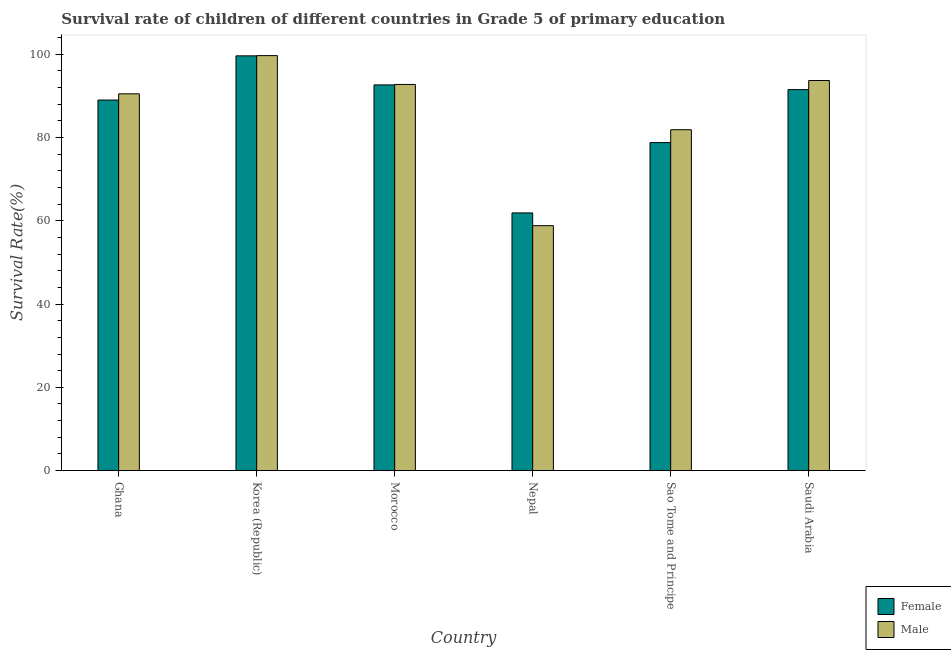How many different coloured bars are there?
Ensure brevity in your answer.  2. How many groups of bars are there?
Make the answer very short. 6. Are the number of bars on each tick of the X-axis equal?
Offer a terse response. Yes. What is the label of the 6th group of bars from the left?
Your answer should be compact. Saudi Arabia. In how many cases, is the number of bars for a given country not equal to the number of legend labels?
Offer a terse response. 0. What is the survival rate of male students in primary education in Korea (Republic)?
Offer a terse response. 99.67. Across all countries, what is the maximum survival rate of female students in primary education?
Keep it short and to the point. 99.62. Across all countries, what is the minimum survival rate of female students in primary education?
Your response must be concise. 61.89. In which country was the survival rate of male students in primary education maximum?
Your response must be concise. Korea (Republic). In which country was the survival rate of female students in primary education minimum?
Offer a very short reply. Nepal. What is the total survival rate of female students in primary education in the graph?
Make the answer very short. 513.42. What is the difference between the survival rate of female students in primary education in Nepal and that in Sao Tome and Principe?
Give a very brief answer. -16.89. What is the difference between the survival rate of female students in primary education in Korea (Republic) and the survival rate of male students in primary education in Nepal?
Give a very brief answer. 40.79. What is the average survival rate of female students in primary education per country?
Keep it short and to the point. 85.57. What is the difference between the survival rate of female students in primary education and survival rate of male students in primary education in Sao Tome and Principe?
Provide a succinct answer. -3.09. In how many countries, is the survival rate of male students in primary education greater than 48 %?
Provide a short and direct response. 6. What is the ratio of the survival rate of female students in primary education in Nepal to that in Sao Tome and Principe?
Make the answer very short. 0.79. Is the survival rate of male students in primary education in Ghana less than that in Morocco?
Give a very brief answer. Yes. Is the difference between the survival rate of female students in primary education in Nepal and Sao Tome and Principe greater than the difference between the survival rate of male students in primary education in Nepal and Sao Tome and Principe?
Keep it short and to the point. Yes. What is the difference between the highest and the second highest survival rate of male students in primary education?
Offer a terse response. 5.98. What is the difference between the highest and the lowest survival rate of female students in primary education?
Offer a terse response. 37.73. Is the sum of the survival rate of male students in primary education in Korea (Republic) and Sao Tome and Principe greater than the maximum survival rate of female students in primary education across all countries?
Your answer should be compact. Yes. What does the 1st bar from the left in Nepal represents?
Make the answer very short. Female. Does the graph contain grids?
Make the answer very short. No. What is the title of the graph?
Give a very brief answer. Survival rate of children of different countries in Grade 5 of primary education. Does "National Visitors" appear as one of the legend labels in the graph?
Your answer should be compact. No. What is the label or title of the Y-axis?
Your response must be concise. Survival Rate(%). What is the Survival Rate(%) of Female in Ghana?
Provide a succinct answer. 89. What is the Survival Rate(%) in Male in Ghana?
Provide a short and direct response. 90.49. What is the Survival Rate(%) in Female in Korea (Republic)?
Provide a short and direct response. 99.62. What is the Survival Rate(%) of Male in Korea (Republic)?
Give a very brief answer. 99.67. What is the Survival Rate(%) of Female in Morocco?
Give a very brief answer. 92.64. What is the Survival Rate(%) in Male in Morocco?
Provide a succinct answer. 92.75. What is the Survival Rate(%) of Female in Nepal?
Provide a short and direct response. 61.89. What is the Survival Rate(%) of Male in Nepal?
Offer a terse response. 58.83. What is the Survival Rate(%) of Female in Sao Tome and Principe?
Ensure brevity in your answer.  78.78. What is the Survival Rate(%) of Male in Sao Tome and Principe?
Give a very brief answer. 81.87. What is the Survival Rate(%) in Female in Saudi Arabia?
Give a very brief answer. 91.5. What is the Survival Rate(%) in Male in Saudi Arabia?
Provide a short and direct response. 93.69. Across all countries, what is the maximum Survival Rate(%) in Female?
Provide a succinct answer. 99.62. Across all countries, what is the maximum Survival Rate(%) in Male?
Your answer should be compact. 99.67. Across all countries, what is the minimum Survival Rate(%) of Female?
Ensure brevity in your answer.  61.89. Across all countries, what is the minimum Survival Rate(%) in Male?
Provide a short and direct response. 58.83. What is the total Survival Rate(%) in Female in the graph?
Offer a terse response. 513.42. What is the total Survival Rate(%) of Male in the graph?
Ensure brevity in your answer.  517.31. What is the difference between the Survival Rate(%) of Female in Ghana and that in Korea (Republic)?
Ensure brevity in your answer.  -10.62. What is the difference between the Survival Rate(%) in Male in Ghana and that in Korea (Republic)?
Your answer should be compact. -9.18. What is the difference between the Survival Rate(%) of Female in Ghana and that in Morocco?
Ensure brevity in your answer.  -3.64. What is the difference between the Survival Rate(%) in Male in Ghana and that in Morocco?
Offer a terse response. -2.25. What is the difference between the Survival Rate(%) of Female in Ghana and that in Nepal?
Give a very brief answer. 27.11. What is the difference between the Survival Rate(%) of Male in Ghana and that in Nepal?
Your answer should be very brief. 31.67. What is the difference between the Survival Rate(%) in Female in Ghana and that in Sao Tome and Principe?
Your response must be concise. 10.22. What is the difference between the Survival Rate(%) in Male in Ghana and that in Sao Tome and Principe?
Your response must be concise. 8.62. What is the difference between the Survival Rate(%) in Female in Ghana and that in Saudi Arabia?
Offer a terse response. -2.5. What is the difference between the Survival Rate(%) in Male in Ghana and that in Saudi Arabia?
Keep it short and to the point. -3.2. What is the difference between the Survival Rate(%) of Female in Korea (Republic) and that in Morocco?
Your answer should be compact. 6.98. What is the difference between the Survival Rate(%) in Male in Korea (Republic) and that in Morocco?
Offer a very short reply. 6.92. What is the difference between the Survival Rate(%) in Female in Korea (Republic) and that in Nepal?
Provide a short and direct response. 37.73. What is the difference between the Survival Rate(%) of Male in Korea (Republic) and that in Nepal?
Offer a terse response. 40.84. What is the difference between the Survival Rate(%) in Female in Korea (Republic) and that in Sao Tome and Principe?
Make the answer very short. 20.84. What is the difference between the Survival Rate(%) in Male in Korea (Republic) and that in Sao Tome and Principe?
Give a very brief answer. 17.8. What is the difference between the Survival Rate(%) in Female in Korea (Republic) and that in Saudi Arabia?
Your answer should be very brief. 8.12. What is the difference between the Survival Rate(%) of Male in Korea (Republic) and that in Saudi Arabia?
Offer a very short reply. 5.98. What is the difference between the Survival Rate(%) in Female in Morocco and that in Nepal?
Your answer should be compact. 30.75. What is the difference between the Survival Rate(%) of Male in Morocco and that in Nepal?
Ensure brevity in your answer.  33.92. What is the difference between the Survival Rate(%) in Female in Morocco and that in Sao Tome and Principe?
Your answer should be very brief. 13.86. What is the difference between the Survival Rate(%) of Male in Morocco and that in Sao Tome and Principe?
Your answer should be compact. 10.87. What is the difference between the Survival Rate(%) of Female in Morocco and that in Saudi Arabia?
Give a very brief answer. 1.14. What is the difference between the Survival Rate(%) in Male in Morocco and that in Saudi Arabia?
Make the answer very short. -0.95. What is the difference between the Survival Rate(%) of Female in Nepal and that in Sao Tome and Principe?
Provide a succinct answer. -16.89. What is the difference between the Survival Rate(%) in Male in Nepal and that in Sao Tome and Principe?
Your response must be concise. -23.05. What is the difference between the Survival Rate(%) of Female in Nepal and that in Saudi Arabia?
Offer a terse response. -29.61. What is the difference between the Survival Rate(%) of Male in Nepal and that in Saudi Arabia?
Provide a short and direct response. -34.87. What is the difference between the Survival Rate(%) of Female in Sao Tome and Principe and that in Saudi Arabia?
Make the answer very short. -12.72. What is the difference between the Survival Rate(%) in Male in Sao Tome and Principe and that in Saudi Arabia?
Your response must be concise. -11.82. What is the difference between the Survival Rate(%) of Female in Ghana and the Survival Rate(%) of Male in Korea (Republic)?
Offer a very short reply. -10.67. What is the difference between the Survival Rate(%) of Female in Ghana and the Survival Rate(%) of Male in Morocco?
Your answer should be very brief. -3.75. What is the difference between the Survival Rate(%) of Female in Ghana and the Survival Rate(%) of Male in Nepal?
Offer a terse response. 30.17. What is the difference between the Survival Rate(%) of Female in Ghana and the Survival Rate(%) of Male in Sao Tome and Principe?
Provide a succinct answer. 7.12. What is the difference between the Survival Rate(%) of Female in Ghana and the Survival Rate(%) of Male in Saudi Arabia?
Ensure brevity in your answer.  -4.7. What is the difference between the Survival Rate(%) of Female in Korea (Republic) and the Survival Rate(%) of Male in Morocco?
Provide a short and direct response. 6.87. What is the difference between the Survival Rate(%) in Female in Korea (Republic) and the Survival Rate(%) in Male in Nepal?
Provide a short and direct response. 40.79. What is the difference between the Survival Rate(%) in Female in Korea (Republic) and the Survival Rate(%) in Male in Sao Tome and Principe?
Provide a succinct answer. 17.74. What is the difference between the Survival Rate(%) of Female in Korea (Republic) and the Survival Rate(%) of Male in Saudi Arabia?
Give a very brief answer. 5.92. What is the difference between the Survival Rate(%) in Female in Morocco and the Survival Rate(%) in Male in Nepal?
Make the answer very short. 33.81. What is the difference between the Survival Rate(%) in Female in Morocco and the Survival Rate(%) in Male in Sao Tome and Principe?
Offer a terse response. 10.76. What is the difference between the Survival Rate(%) in Female in Morocco and the Survival Rate(%) in Male in Saudi Arabia?
Your response must be concise. -1.06. What is the difference between the Survival Rate(%) in Female in Nepal and the Survival Rate(%) in Male in Sao Tome and Principe?
Keep it short and to the point. -19.98. What is the difference between the Survival Rate(%) in Female in Nepal and the Survival Rate(%) in Male in Saudi Arabia?
Offer a terse response. -31.81. What is the difference between the Survival Rate(%) in Female in Sao Tome and Principe and the Survival Rate(%) in Male in Saudi Arabia?
Provide a short and direct response. -14.91. What is the average Survival Rate(%) in Female per country?
Offer a very short reply. 85.57. What is the average Survival Rate(%) of Male per country?
Give a very brief answer. 86.22. What is the difference between the Survival Rate(%) of Female and Survival Rate(%) of Male in Ghana?
Give a very brief answer. -1.5. What is the difference between the Survival Rate(%) in Female and Survival Rate(%) in Male in Korea (Republic)?
Offer a very short reply. -0.05. What is the difference between the Survival Rate(%) of Female and Survival Rate(%) of Male in Morocco?
Offer a terse response. -0.11. What is the difference between the Survival Rate(%) of Female and Survival Rate(%) of Male in Nepal?
Make the answer very short. 3.06. What is the difference between the Survival Rate(%) in Female and Survival Rate(%) in Male in Sao Tome and Principe?
Give a very brief answer. -3.09. What is the difference between the Survival Rate(%) of Female and Survival Rate(%) of Male in Saudi Arabia?
Give a very brief answer. -2.19. What is the ratio of the Survival Rate(%) in Female in Ghana to that in Korea (Republic)?
Provide a succinct answer. 0.89. What is the ratio of the Survival Rate(%) in Male in Ghana to that in Korea (Republic)?
Your answer should be compact. 0.91. What is the ratio of the Survival Rate(%) of Female in Ghana to that in Morocco?
Ensure brevity in your answer.  0.96. What is the ratio of the Survival Rate(%) in Male in Ghana to that in Morocco?
Ensure brevity in your answer.  0.98. What is the ratio of the Survival Rate(%) in Female in Ghana to that in Nepal?
Give a very brief answer. 1.44. What is the ratio of the Survival Rate(%) in Male in Ghana to that in Nepal?
Ensure brevity in your answer.  1.54. What is the ratio of the Survival Rate(%) in Female in Ghana to that in Sao Tome and Principe?
Make the answer very short. 1.13. What is the ratio of the Survival Rate(%) in Male in Ghana to that in Sao Tome and Principe?
Make the answer very short. 1.11. What is the ratio of the Survival Rate(%) of Female in Ghana to that in Saudi Arabia?
Your answer should be compact. 0.97. What is the ratio of the Survival Rate(%) of Male in Ghana to that in Saudi Arabia?
Your answer should be very brief. 0.97. What is the ratio of the Survival Rate(%) of Female in Korea (Republic) to that in Morocco?
Offer a very short reply. 1.08. What is the ratio of the Survival Rate(%) of Male in Korea (Republic) to that in Morocco?
Provide a short and direct response. 1.07. What is the ratio of the Survival Rate(%) in Female in Korea (Republic) to that in Nepal?
Keep it short and to the point. 1.61. What is the ratio of the Survival Rate(%) in Male in Korea (Republic) to that in Nepal?
Your answer should be compact. 1.69. What is the ratio of the Survival Rate(%) in Female in Korea (Republic) to that in Sao Tome and Principe?
Offer a very short reply. 1.26. What is the ratio of the Survival Rate(%) of Male in Korea (Republic) to that in Sao Tome and Principe?
Your answer should be compact. 1.22. What is the ratio of the Survival Rate(%) in Female in Korea (Republic) to that in Saudi Arabia?
Offer a very short reply. 1.09. What is the ratio of the Survival Rate(%) in Male in Korea (Republic) to that in Saudi Arabia?
Provide a succinct answer. 1.06. What is the ratio of the Survival Rate(%) of Female in Morocco to that in Nepal?
Offer a very short reply. 1.5. What is the ratio of the Survival Rate(%) of Male in Morocco to that in Nepal?
Your answer should be very brief. 1.58. What is the ratio of the Survival Rate(%) in Female in Morocco to that in Sao Tome and Principe?
Offer a terse response. 1.18. What is the ratio of the Survival Rate(%) in Male in Morocco to that in Sao Tome and Principe?
Offer a very short reply. 1.13. What is the ratio of the Survival Rate(%) in Female in Morocco to that in Saudi Arabia?
Provide a short and direct response. 1.01. What is the ratio of the Survival Rate(%) of Male in Morocco to that in Saudi Arabia?
Your answer should be compact. 0.99. What is the ratio of the Survival Rate(%) of Female in Nepal to that in Sao Tome and Principe?
Make the answer very short. 0.79. What is the ratio of the Survival Rate(%) in Male in Nepal to that in Sao Tome and Principe?
Keep it short and to the point. 0.72. What is the ratio of the Survival Rate(%) of Female in Nepal to that in Saudi Arabia?
Provide a short and direct response. 0.68. What is the ratio of the Survival Rate(%) in Male in Nepal to that in Saudi Arabia?
Ensure brevity in your answer.  0.63. What is the ratio of the Survival Rate(%) of Female in Sao Tome and Principe to that in Saudi Arabia?
Make the answer very short. 0.86. What is the ratio of the Survival Rate(%) in Male in Sao Tome and Principe to that in Saudi Arabia?
Ensure brevity in your answer.  0.87. What is the difference between the highest and the second highest Survival Rate(%) in Female?
Ensure brevity in your answer.  6.98. What is the difference between the highest and the second highest Survival Rate(%) of Male?
Your answer should be very brief. 5.98. What is the difference between the highest and the lowest Survival Rate(%) in Female?
Ensure brevity in your answer.  37.73. What is the difference between the highest and the lowest Survival Rate(%) of Male?
Provide a short and direct response. 40.84. 